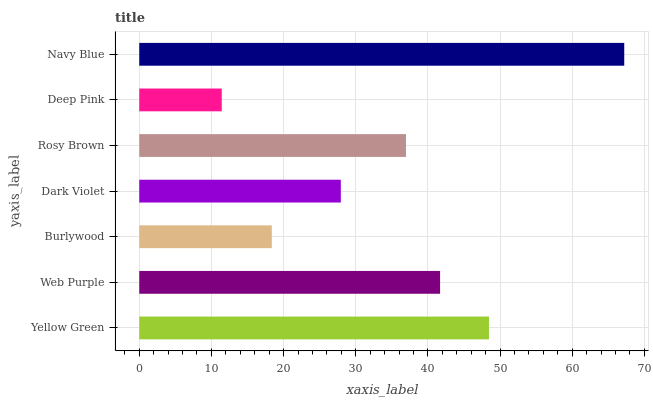Is Deep Pink the minimum?
Answer yes or no. Yes. Is Navy Blue the maximum?
Answer yes or no. Yes. Is Web Purple the minimum?
Answer yes or no. No. Is Web Purple the maximum?
Answer yes or no. No. Is Yellow Green greater than Web Purple?
Answer yes or no. Yes. Is Web Purple less than Yellow Green?
Answer yes or no. Yes. Is Web Purple greater than Yellow Green?
Answer yes or no. No. Is Yellow Green less than Web Purple?
Answer yes or no. No. Is Rosy Brown the high median?
Answer yes or no. Yes. Is Rosy Brown the low median?
Answer yes or no. Yes. Is Dark Violet the high median?
Answer yes or no. No. Is Deep Pink the low median?
Answer yes or no. No. 